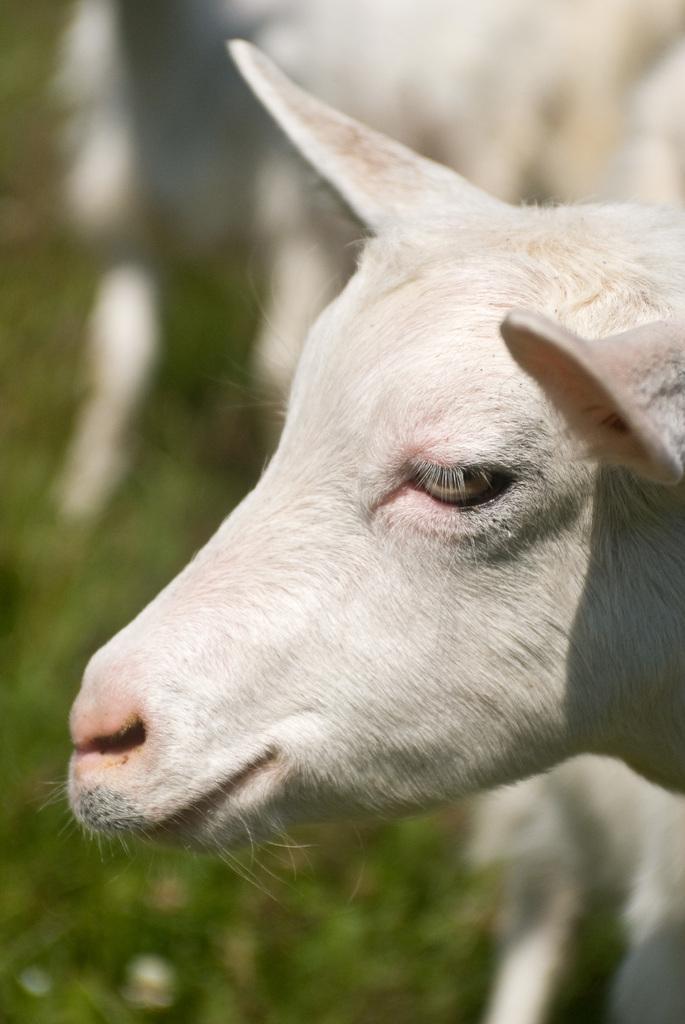How would you summarize this image in a sentence or two? In this picture we can see a sheep face. 